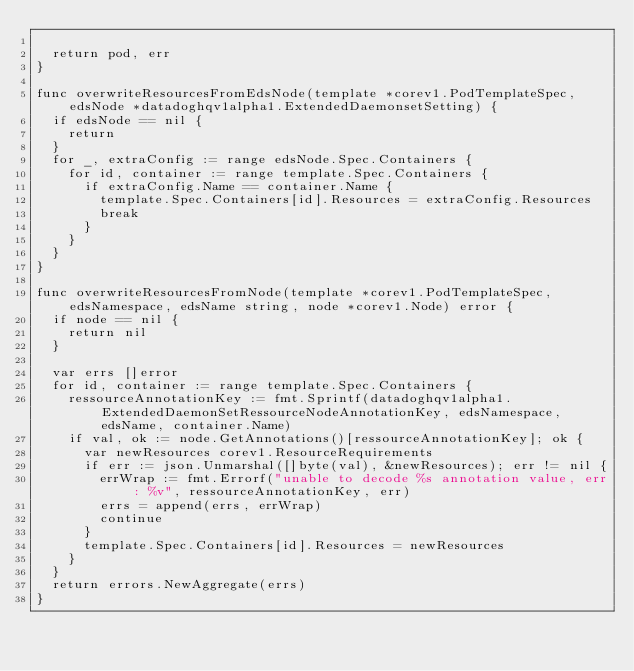<code> <loc_0><loc_0><loc_500><loc_500><_Go_>
	return pod, err
}

func overwriteResourcesFromEdsNode(template *corev1.PodTemplateSpec, edsNode *datadoghqv1alpha1.ExtendedDaemonsetSetting) {
	if edsNode == nil {
		return
	}
	for _, extraConfig := range edsNode.Spec.Containers {
		for id, container := range template.Spec.Containers {
			if extraConfig.Name == container.Name {
				template.Spec.Containers[id].Resources = extraConfig.Resources
				break
			}
		}
	}
}

func overwriteResourcesFromNode(template *corev1.PodTemplateSpec, edsNamespace, edsName string, node *corev1.Node) error {
	if node == nil {
		return nil
	}

	var errs []error
	for id, container := range template.Spec.Containers {
		ressourceAnnotationKey := fmt.Sprintf(datadoghqv1alpha1.ExtendedDaemonSetRessourceNodeAnnotationKey, edsNamespace, edsName, container.Name)
		if val, ok := node.GetAnnotations()[ressourceAnnotationKey]; ok {
			var newResources corev1.ResourceRequirements
			if err := json.Unmarshal([]byte(val), &newResources); err != nil {
				errWrap := fmt.Errorf("unable to decode %s annotation value, err: %v", ressourceAnnotationKey, err)
				errs = append(errs, errWrap)
				continue
			}
			template.Spec.Containers[id].Resources = newResources
		}
	}
	return errors.NewAggregate(errs)
}
</code> 